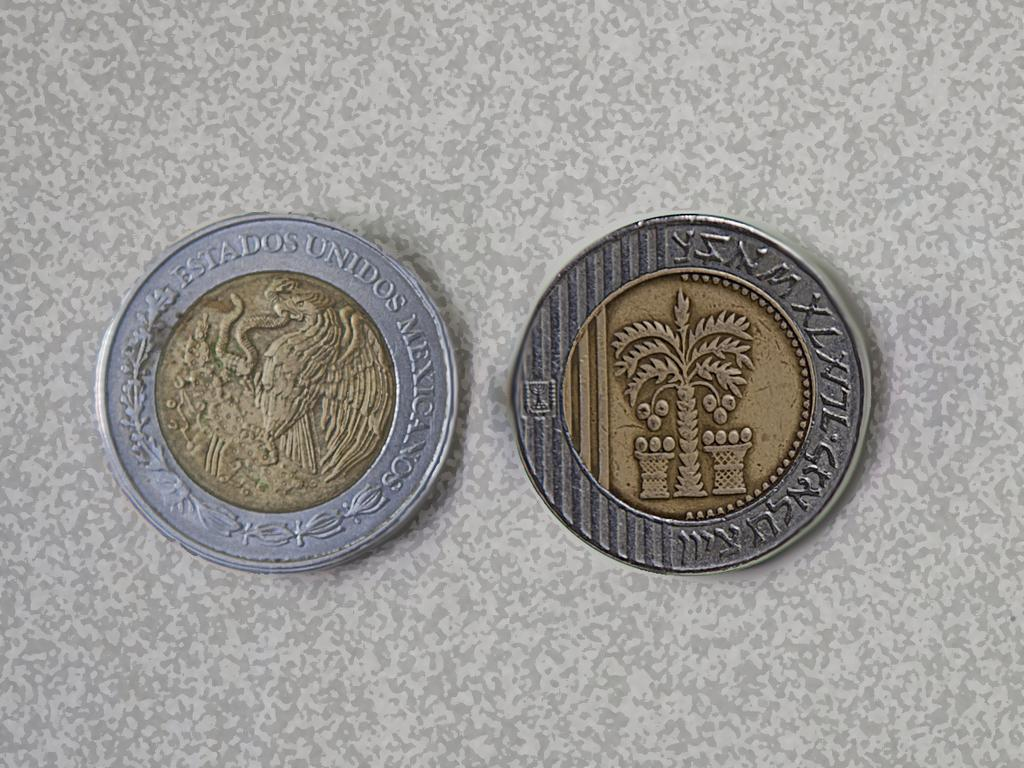Provide a one-sentence caption for the provided image. The front and back of a coin with gold centers and silver bands transcribe with Estados Unidos Mexicanos. 